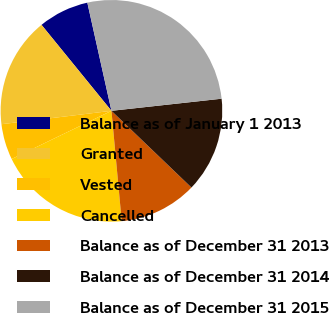<chart> <loc_0><loc_0><loc_500><loc_500><pie_chart><fcel>Balance as of January 1 2013<fcel>Granted<fcel>Vested<fcel>Cancelled<fcel>Balance as of December 31 2013<fcel>Balance as of December 31 2014<fcel>Balance as of December 31 2015<nl><fcel>7.38%<fcel>16.06%<fcel>5.23%<fcel>19.32%<fcel>11.36%<fcel>13.91%<fcel>26.75%<nl></chart> 